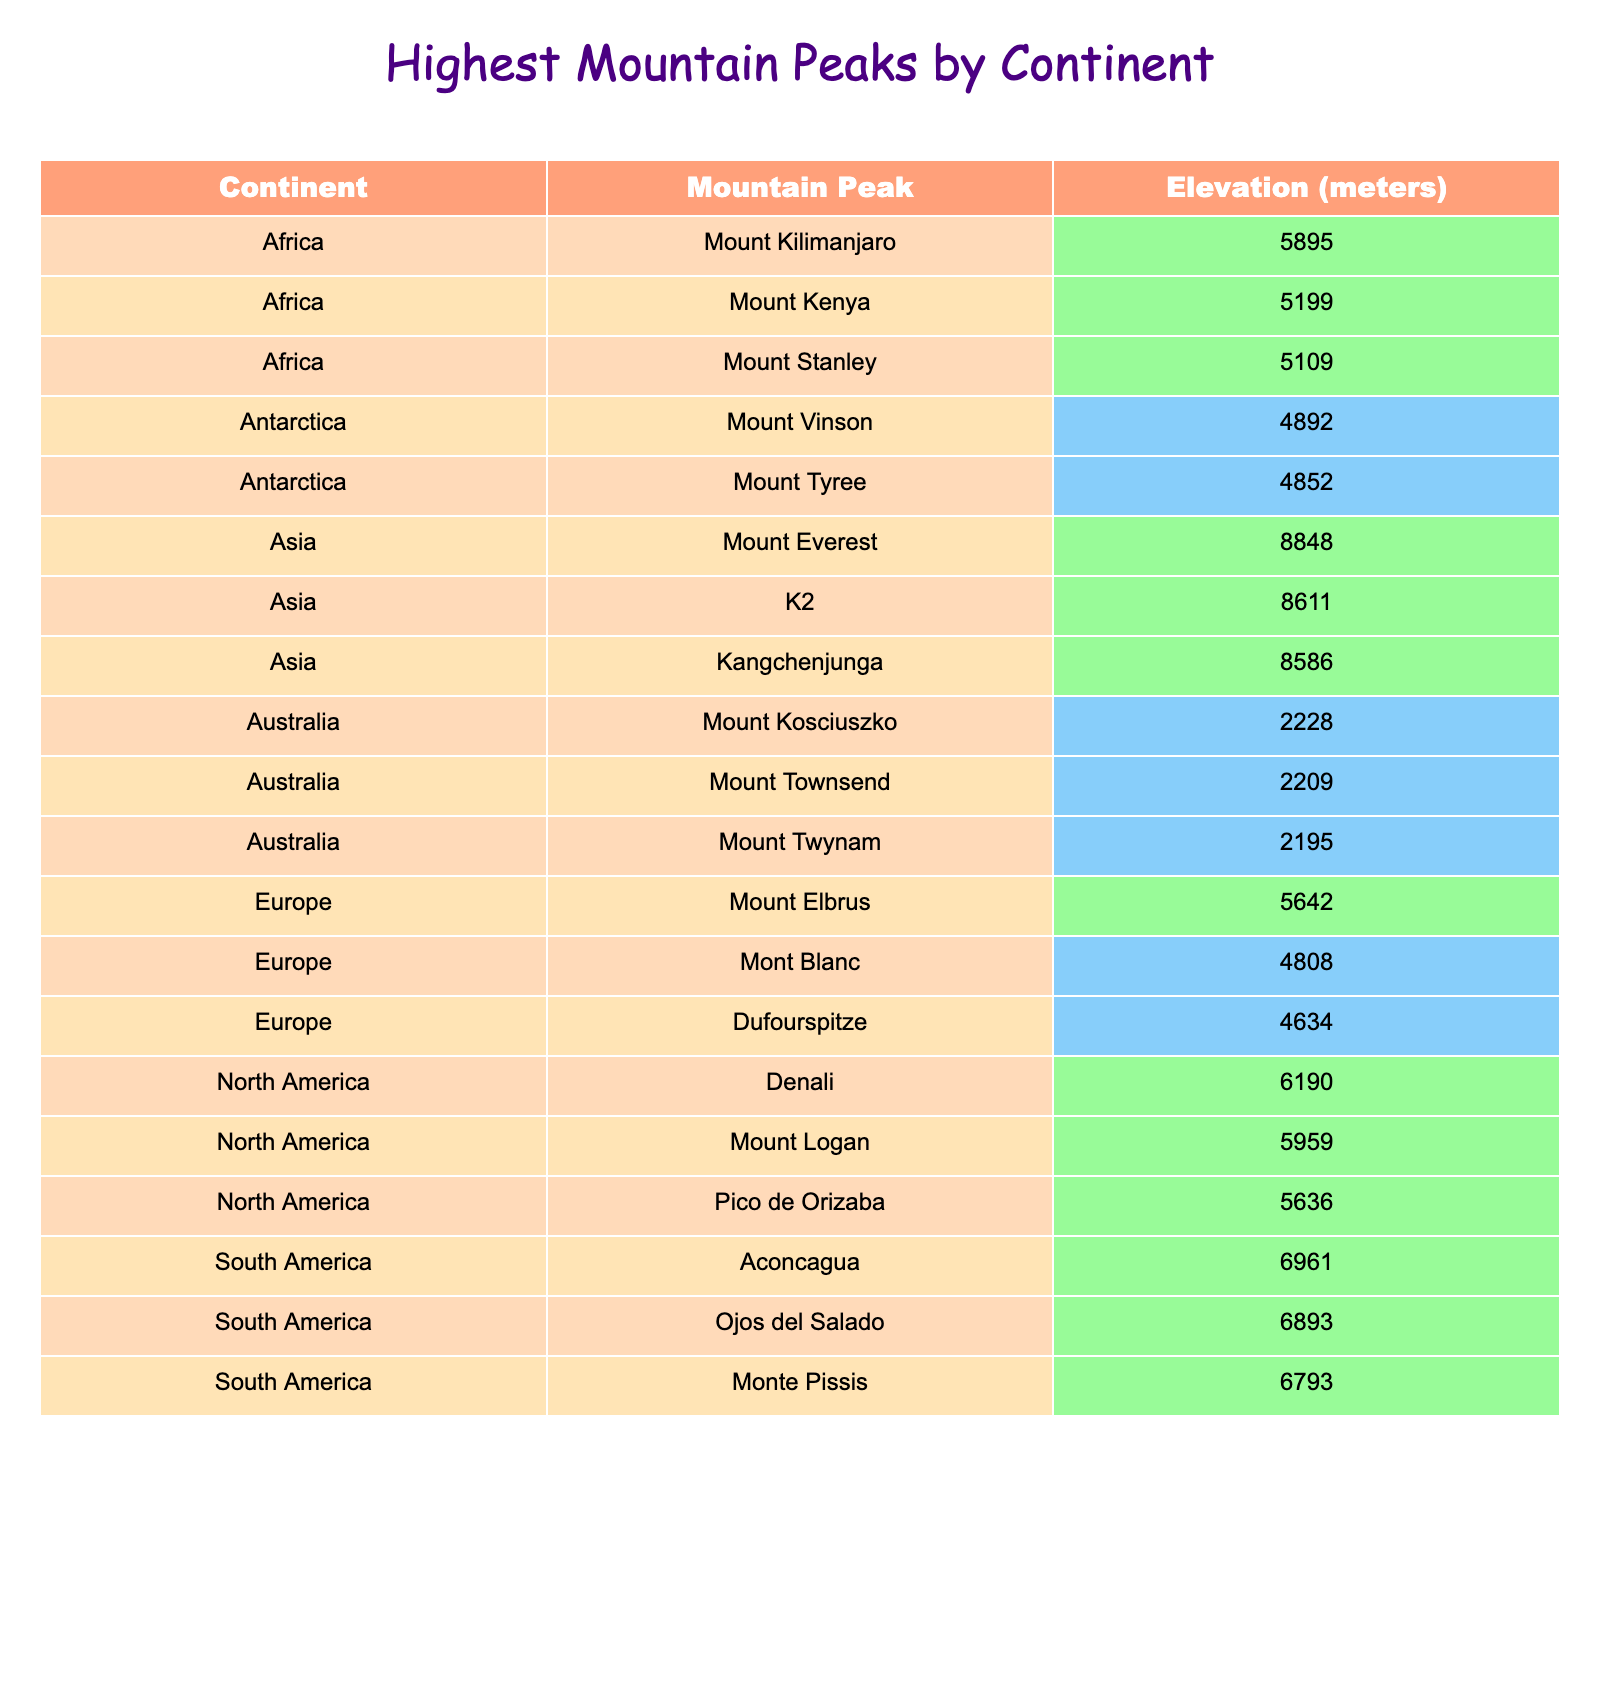What is the highest mountain peak in South America? The table indicates that the highest peak in South America is Aconcagua, with an elevation of 6961 meters.
Answer: Aconcagua Which continent has the highest mountain peak? Upon reviewing the table, Mount Everest, located in Asia, is recorded as the highest mountain peak at 8848 meters.
Answer: Asia How many mountain peaks listed have elevations above 5000 meters? By scanning the table, we can see that there are 7 mountain peaks with elevations exceeding 5000 meters: Mount Kilimanjaro, Mount Everest, Denali, Aconcagua, K2, Kangchenjunga, and Mount Logan.
Answer: 7 What is the elevation difference between Mount Vinson and Mount Elbrus? The elevation of Mount Vinson is 4892 meters and that of Mount Elbrus is 5642 meters. The difference is calculated as 5642 - 4892 = 750 meters.
Answer: 750 meters Is Mount Kilimanjaro higher than Mount Kenya? According to the table, Mount Kilimanjaro is at 5895 meters, while Mount Kenya is 5199 meters, meaning Mount Kilimanjaro is indeed higher.
Answer: Yes What is the average elevation of the mountain peaks in Antarctica? The table shows that the mountain peaks in Antarctica are Mount Vinson (4892 meters) and Mount Tyree (4852 meters). Their average elevation is calculated by (4892 + 4852) / 2 = 4872 meters.
Answer: 4872 meters Which mountain peak has the lowest elevation in the table? Looking through the table, we can see that Mount Kosciuszko has the lowest elevation at 2228 meters.
Answer: Mount Kosciuszko How many more meters is Denali taller than Mount Kosciuszko? Denali's elevation is 6190 meters and Mount Kosciuszko's elevation is 2228 meters. The difference is calculated as 6190 - 2228 = 3962 meters.
Answer: 3962 meters Does Asia have more than three mountain peaks with elevations above 8000 meters? The table shows that Asia has two peaks above 8000 meters: Mount Everest (8848 m) and K2 (8611 m), thus the statement is false.
Answer: No Which mountain peak is second highest in Asia? By checking the table, the second highest peak in Asia is K2 at 8611 meters.
Answer: K2 